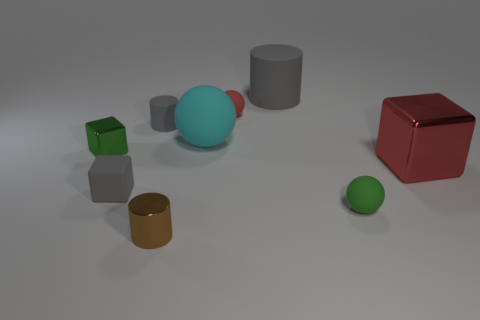Can you tell me which objects stand out due to their distinct shape? The red cube stands out because of its precise edges and corners, contrasting with the more rounded shapes of the other objects. Is there any significance to the positioning of these objects? While it's not clear if there's an intended significance, the objects' arrangement does create a visually engaging balance of forms and colors. 